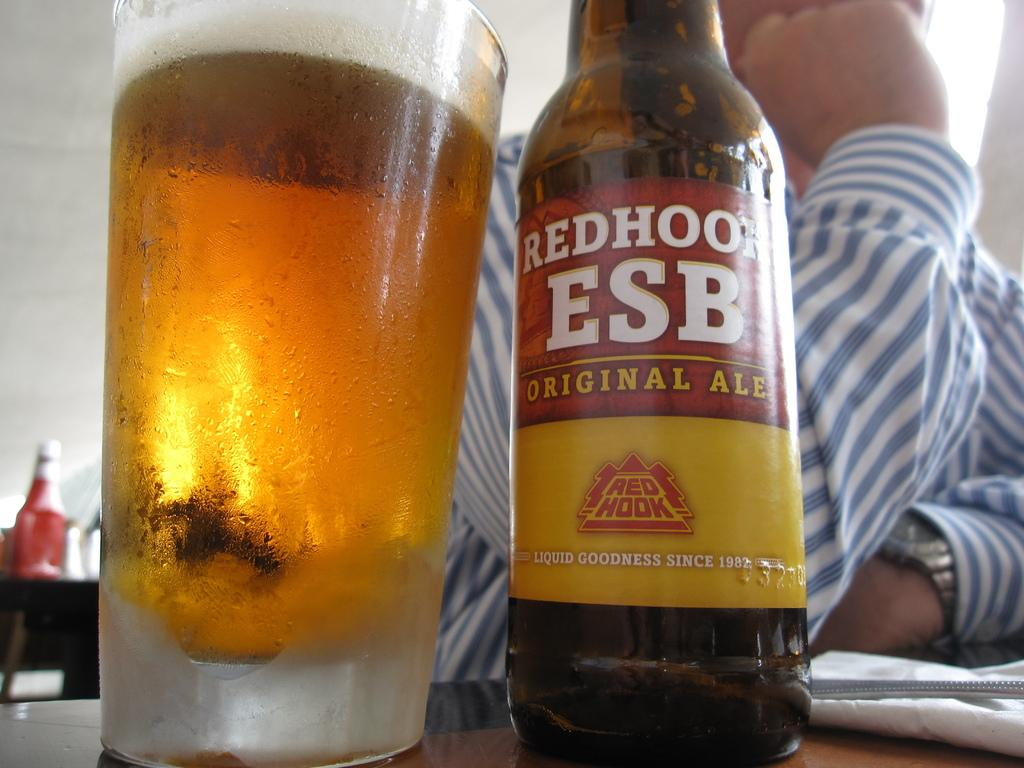<image>
Write a terse but informative summary of the picture. Bottle of beer named RED HOOK next to a cup of beer. 